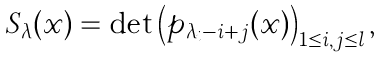Convert formula to latex. <formula><loc_0><loc_0><loc_500><loc_500>S _ { \lambda } ( { \boldsymbol x } ) = \det \left ( p _ { \lambda _ { i } - i + j } ( { \boldsymbol x } ) \right ) _ { 1 \leq i , j \leq l } ,</formula> 